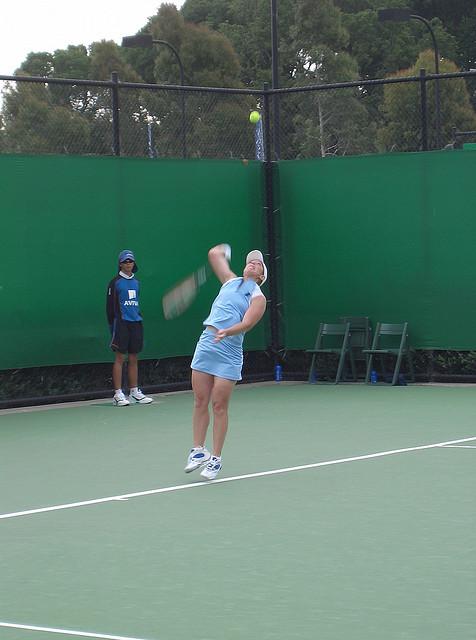Is the player going to use a forehand stroke?
Quick response, please. Yes. How many chairs are available?
Give a very brief answer. 2. What is the women about to hit?
Give a very brief answer. Tennis ball. Why is a person behind the server?
Concise answer only. Watching. 